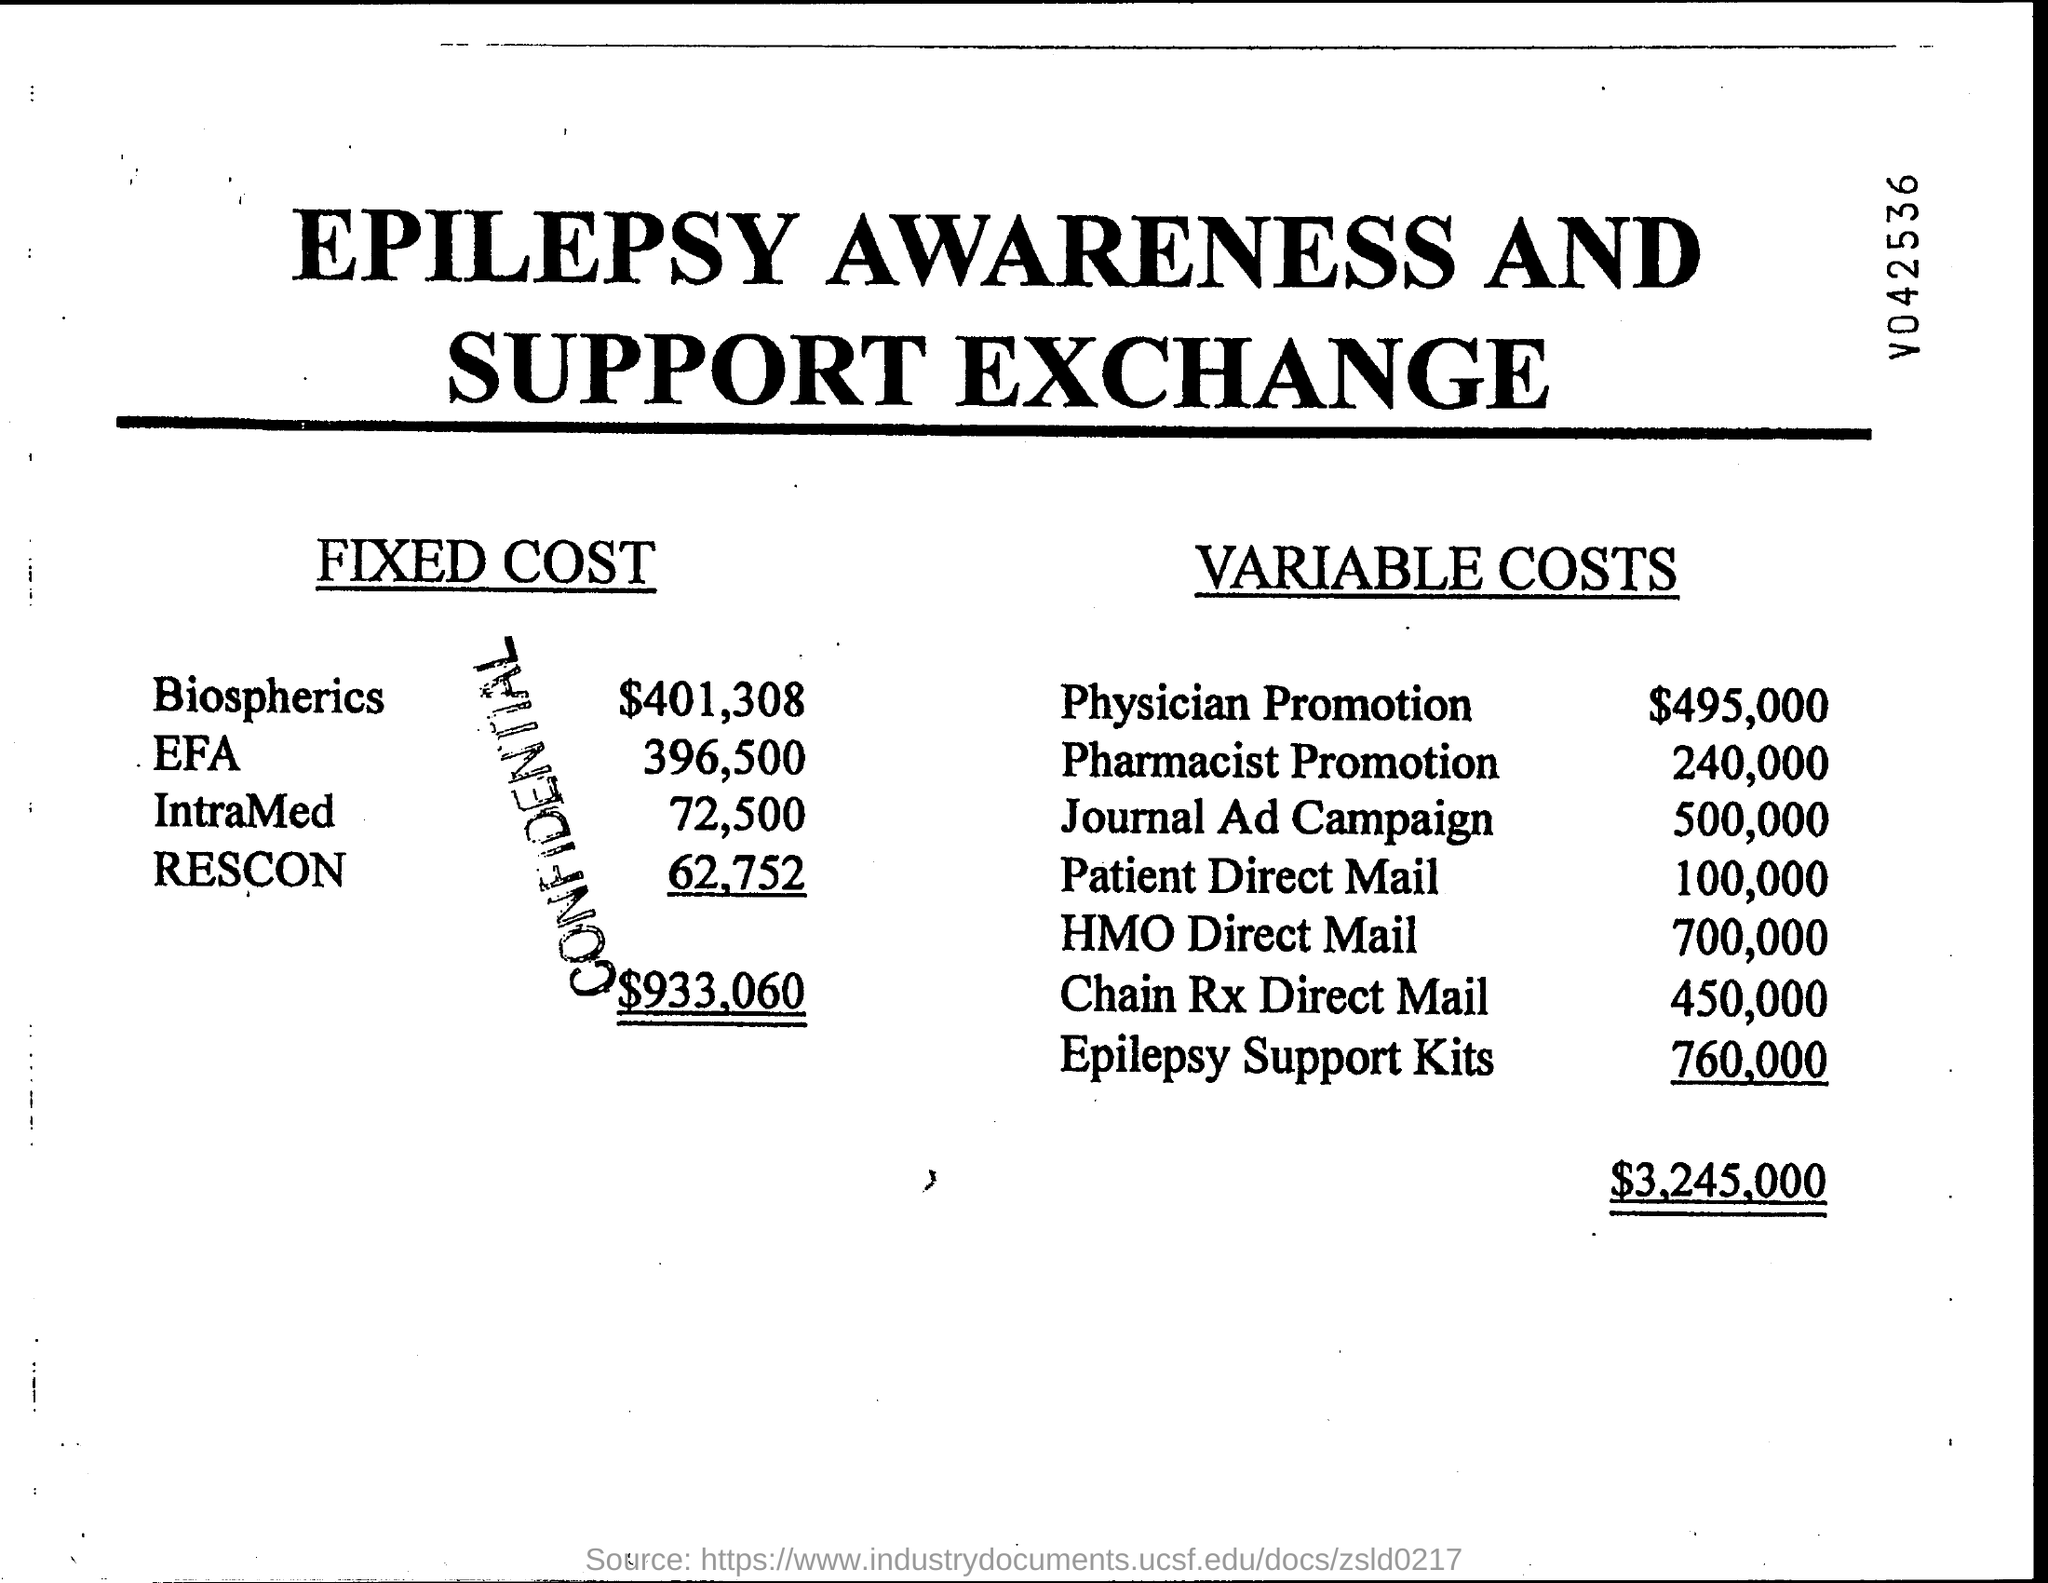Highlight a few significant elements in this photo. The total fixed cost is $933,060. The amount of physician promotion in variable costs is $495,000. The total of variable costs is $3,245,000. The fixed costs for Biospherics are $401,308. 